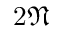Convert formula to latex. <formula><loc_0><loc_0><loc_500><loc_500>2 \mathfrak { N }</formula> 